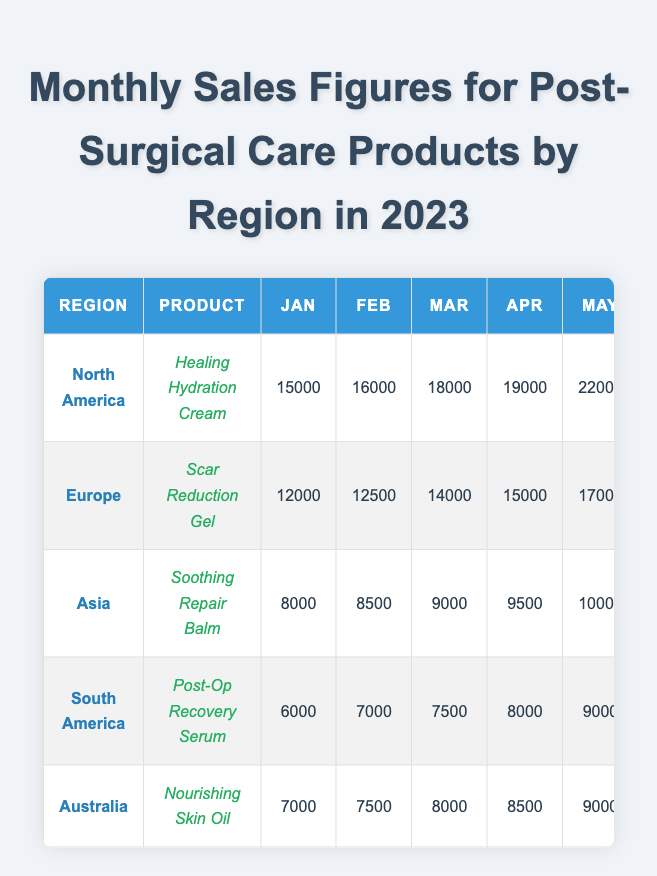What is the total sales for Healing Hydration Cream in North America for 2023? To find the total sales, I will add the monthly sales figures for the Healing Hydration Cream: 15000 + 16000 + 18000 + 19000 + 22000 + 24000 + 25000 + 23000 + 26000 + 28000 + 30000 + 32000 =  288000.
Answer: 288000 Which region made the most sales in December? Checking the sales figures for December, North America shows 32000, Europe 26000, Asia 15000, South America 12000, and Australia 14000. North America has the highest sales in December.
Answer: North America What was the average monthly sales for the Scar Reduction Gel in Europe? To find the average, sum the monthly sales (12000 + 12500 + 14000 + 15000 + 17000 + 18000 + 20000 + 19000 + 21000 + 23000 + 24000 + 26000 = 218500) and divide by 12, which results in 218500 / 12 = 18125.
Answer: 18125 Did South America consistently have rising sales for the Post-Op Recovery Serum throughout the year? Reviewing the sales figures: January 6000, February 7000, March 7500, April 8000, May 9000, June 9500, July 10000, August 8500, September 9000, October 9500, November 11000, December 12000; sales did not consistently rise since August saw a decrease from July.
Answer: No What was the sales trend for Soothing Repair Balm in Asia throughout the year? Analyzing the sales figures month by month: February (8500), March (9000), April (9500), May (10000), June (11500), July (12000), August (11000), September (12500), October (13000), November (14000), December (15000). Overall, there were increases until August, after which sales experienced one decline before continuing to rise.
Answer: Generally upward with one decline Which product had the lowest sales figure in a single month across all regions? The lowest monthly sales figures can be found by reviewing each product's sales: South America’s Post-Op Recovery Serum had the lowest value in January at 6000.
Answer: 6000 What is the total sales of products in Australia for the year? Summing the monthly sales of Nourishing Skin Oil: 7000 + 7500 + 8000 + 8500 + 9000 + 10000 + 11000 + 10500 + 11500 + 12500 + 13000 + 14000 = 115500.
Answer: 115500 Was there a month in which Europe outperformed Asia in sales for their respective products? Examining the monthly sales: For January, Europe (12000) outperformed Asia (8000); for February, Europe (12500) outperformed Asia (8500); similar results occurred in all months until December, indicating Europe outperformed Asia consistently.
Answer: Yes 